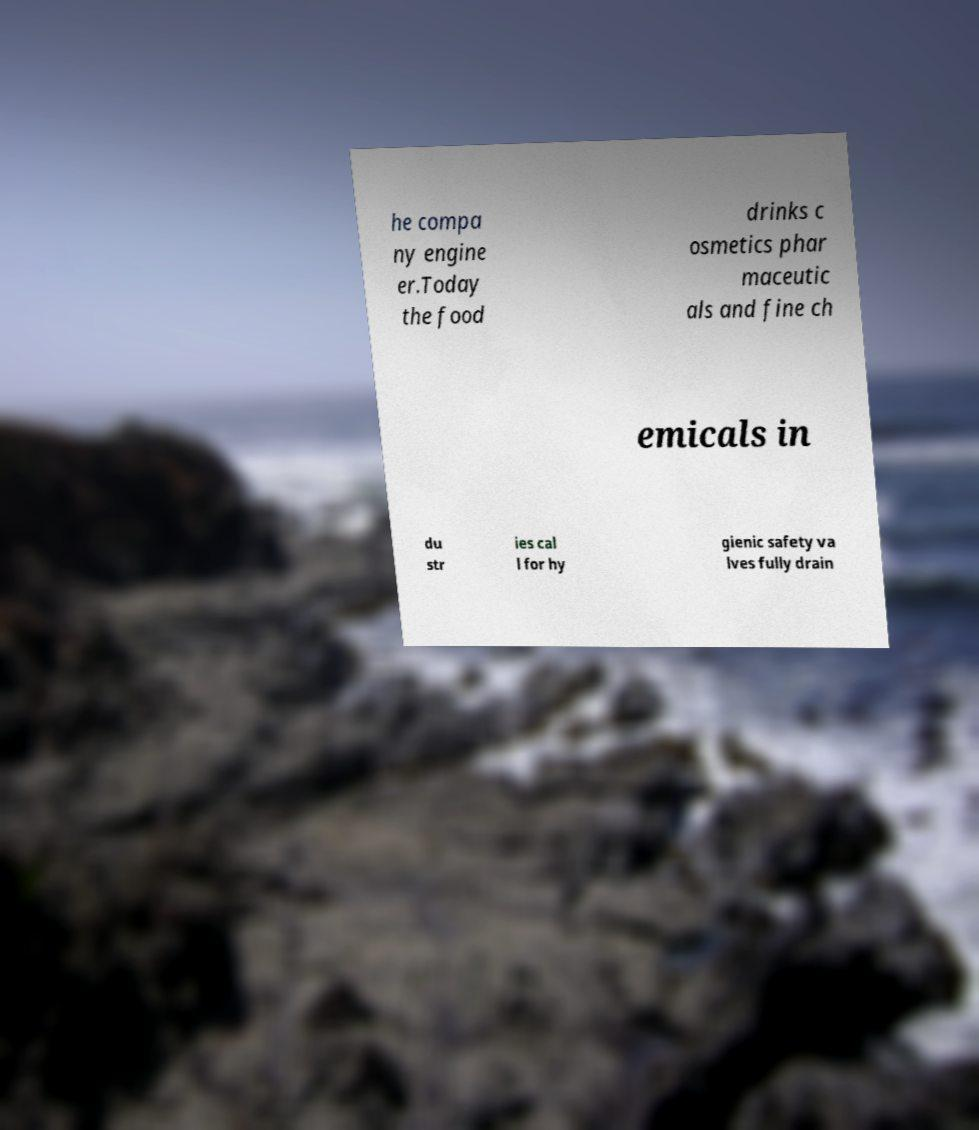For documentation purposes, I need the text within this image transcribed. Could you provide that? he compa ny engine er.Today the food drinks c osmetics phar maceutic als and fine ch emicals in du str ies cal l for hy gienic safety va lves fully drain 